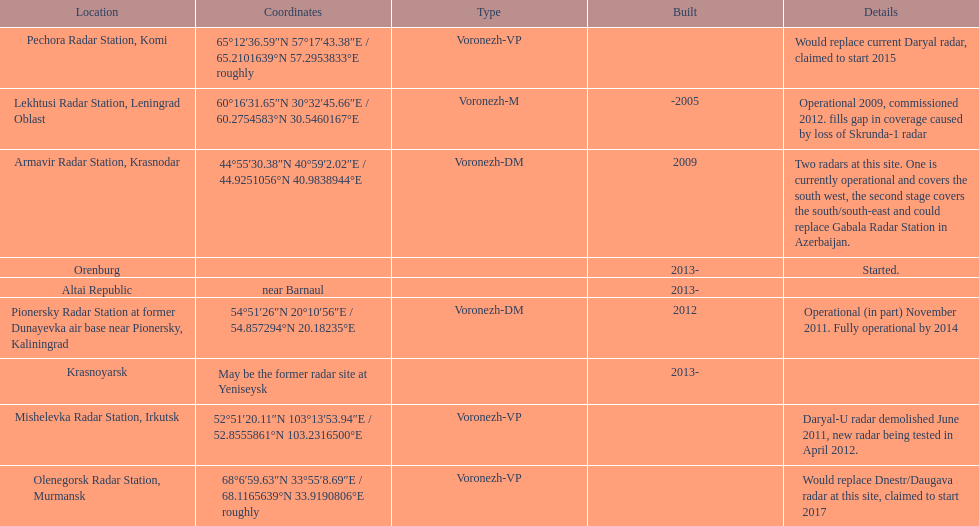What is the only location with a coordination of 60°16&#8242;31.65&#8243;n 30°32&#8242;45.66&#8243;e / 60.2754583°n 30.5460167°e? Lekhtusi Radar Station, Leningrad Oblast. 